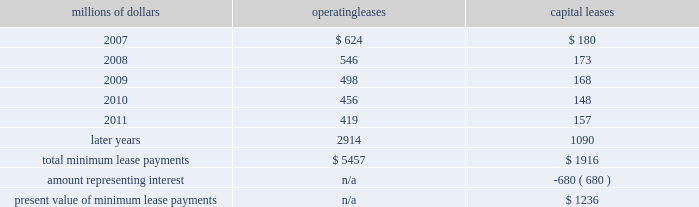Depending upon our senior unsecured debt ratings .
The facilities require the maintenance of a minimum net worth and a debt to net worth coverage ratio .
At december 31 , 2006 , we were in compliance with these covenants .
The facilities do not include any other financial restrictions , credit rating triggers ( other than rating-dependent pricing ) , or any other provision that could require the posting of collateral .
In addition to our revolving credit facilities , we had $ 150 million in uncommitted lines of credit available , including $ 75 million that expires in march 2007 and $ 75 million expiring in may 2007 .
Neither of these lines of credit were used as of december 31 , 2006 .
We must have equivalent credit available under our five-year facilities to draw on these $ 75 million lines .
Dividend restrictions 2013 we are subject to certain restrictions related to the payment of cash dividends to our shareholders due to minimum net worth requirements under the credit facilities referred to above .
The amount of retained earnings available for dividends was $ 7.8 billion and $ 6.2 billion at december 31 , 2006 and 2005 , respectively .
We do not expect that these restrictions will have a material adverse effect on our consolidated financial condition , results of operations , or liquidity .
We declared dividends of $ 323 million in 2006 and $ 316 million in 2005 .
Shelf registration statement 2013 under a current shelf registration statement , we may issue any combination of debt securities , preferred stock , common stock , or warrants for debt securities or preferred stock in one or more offerings .
At december 31 , 2006 , we had $ 500 million remaining for issuance under the current shelf registration statement .
We have no immediate plans to issue any securities ; however , we routinely consider and evaluate opportunities to replace existing debt or access capital through issuances of debt securities under this shelf registration , and , therefore , we may issue debt securities at any time .
Leases we lease certain locomotives , freight cars , and other property .
Future minimum lease payments for operating and capital leases with initial or remaining non-cancelable lease terms in excess of one year as of december 31 , 2006 were as follows : millions of dollars operating leases capital leases .
Rent expense for operating leases with terms exceeding one month was $ 798 million in 2006 , $ 728 million in 2005 , and $ 651 million in 2004 .
When cash rental payments are not made on a straight-line basis , we recognize variable rental expense on a straight-line basis over the lease term .
Contingent rentals and sub-rentals are not significant. .
In 2006 what was the percentage of the dividends declared to the amount available in retained earnings for dividends? 
Computations: (323 / 7.8)
Answer: 41.41026. 